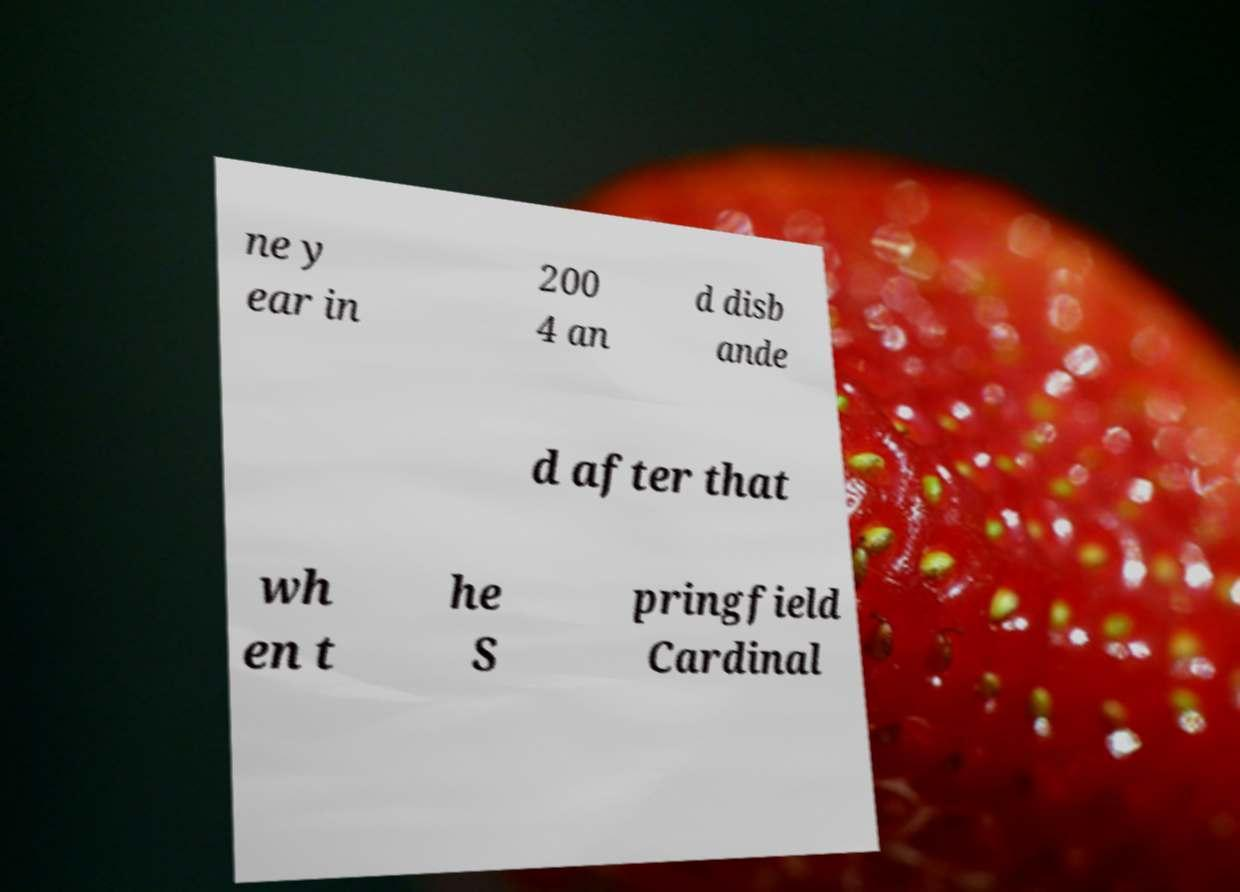Please read and relay the text visible in this image. What does it say? ne y ear in 200 4 an d disb ande d after that wh en t he S pringfield Cardinal 